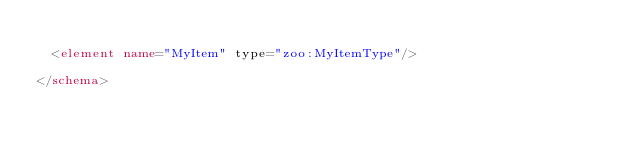Convert code to text. <code><loc_0><loc_0><loc_500><loc_500><_XML_>
  <element name="MyItem" type="zoo:MyItemType"/>

</schema>
</code> 